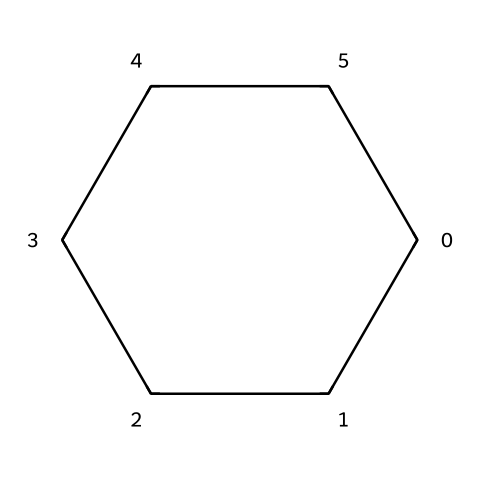What is the name of this chemical structure? The SMILES representation "C1CCCCC1" indicates a six-membered carbon ring with no double bonds, identifying it as cyclohexane.
Answer: cyclohexane How many carbon atoms are present in this structure? The SMILES notation "C1CCCCC1" shows there are six carbon atoms in the cyclic arrangement.
Answer: six What is the degree of saturation for cyclohexane? Cyclohexane is a saturated hydrocarbon with no double or triple bonds, thus having a degree of saturation of zero.
Answer: zero How many hydrogen atoms are bonded to this molecule? Each carbon atom in cyclohexane is bonded to two hydrogen atoms, which gives a total of twelve hydrogen atoms (6 carbons x 2 hydrogens = 12).
Answer: twelve Is cyclohexane a cyclic or acyclic compound? The presence of the ring structure in the SMILES notation specifies that this compound is cyclic.
Answer: cyclic What type of isomerism is exhibited by cyclohexane? Cyclohexane does not exhibit structural isomerism as it has only one structure due to its saturated nature and symmetry.
Answer: none 